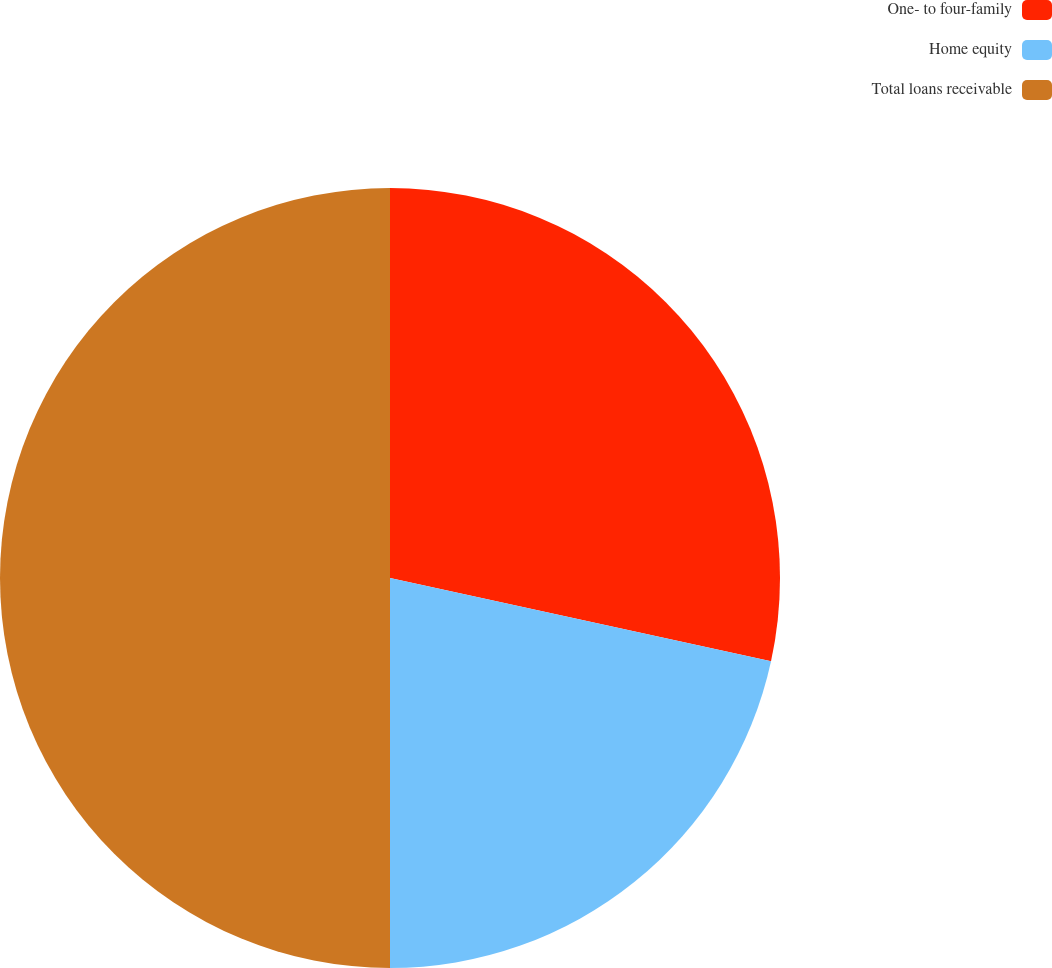<chart> <loc_0><loc_0><loc_500><loc_500><pie_chart><fcel>One- to four-family<fcel>Home equity<fcel>Total loans receivable<nl><fcel>28.42%<fcel>21.58%<fcel>50.0%<nl></chart> 